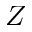<formula> <loc_0><loc_0><loc_500><loc_500>Z</formula> 